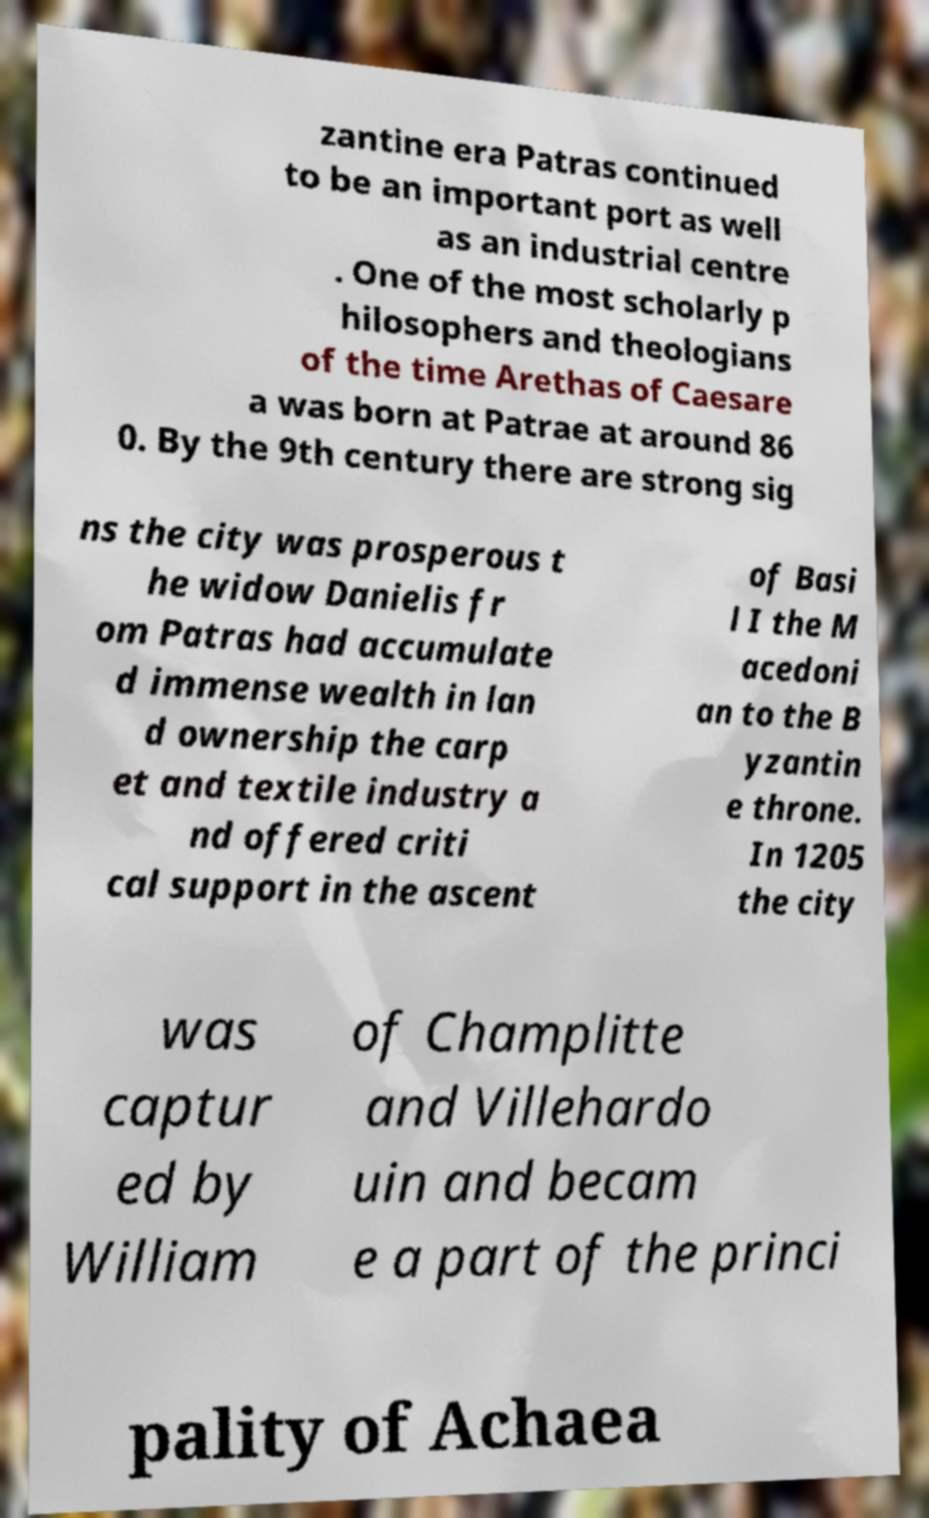Please read and relay the text visible in this image. What does it say? zantine era Patras continued to be an important port as well as an industrial centre . One of the most scholarly p hilosophers and theologians of the time Arethas of Caesare a was born at Patrae at around 86 0. By the 9th century there are strong sig ns the city was prosperous t he widow Danielis fr om Patras had accumulate d immense wealth in lan d ownership the carp et and textile industry a nd offered criti cal support in the ascent of Basi l I the M acedoni an to the B yzantin e throne. In 1205 the city was captur ed by William of Champlitte and Villehardo uin and becam e a part of the princi pality of Achaea 